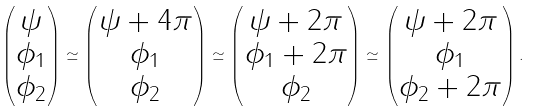Convert formula to latex. <formula><loc_0><loc_0><loc_500><loc_500>\begin{pmatrix} \psi \\ \phi _ { 1 } \\ \phi _ { 2 } \end{pmatrix} \simeq \begin{pmatrix} \psi + 4 \pi \\ \phi _ { 1 } \\ \phi _ { 2 } \end{pmatrix} \simeq \begin{pmatrix} \psi + 2 \pi \\ \phi _ { 1 } + 2 \pi \\ \phi _ { 2 } \end{pmatrix} \simeq \begin{pmatrix} \psi + 2 \pi \\ \phi _ { 1 } \\ \phi _ { 2 } + 2 \pi \end{pmatrix} .</formula> 